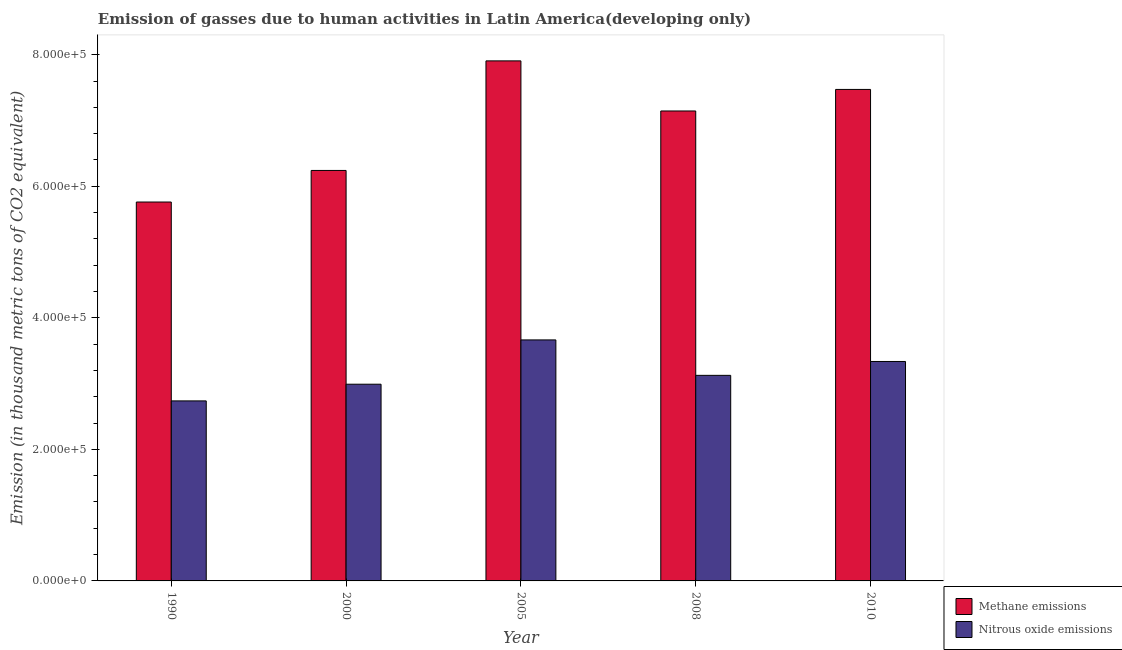How many different coloured bars are there?
Offer a terse response. 2. How many groups of bars are there?
Make the answer very short. 5. Are the number of bars per tick equal to the number of legend labels?
Ensure brevity in your answer.  Yes. Are the number of bars on each tick of the X-axis equal?
Provide a short and direct response. Yes. What is the amount of nitrous oxide emissions in 2010?
Offer a very short reply. 3.34e+05. Across all years, what is the maximum amount of methane emissions?
Provide a short and direct response. 7.91e+05. Across all years, what is the minimum amount of nitrous oxide emissions?
Give a very brief answer. 2.74e+05. In which year was the amount of methane emissions maximum?
Your answer should be compact. 2005. In which year was the amount of methane emissions minimum?
Offer a terse response. 1990. What is the total amount of methane emissions in the graph?
Offer a very short reply. 3.45e+06. What is the difference between the amount of nitrous oxide emissions in 2000 and that in 2008?
Keep it short and to the point. -1.35e+04. What is the difference between the amount of methane emissions in 2005 and the amount of nitrous oxide emissions in 2010?
Offer a very short reply. 4.34e+04. What is the average amount of nitrous oxide emissions per year?
Your response must be concise. 3.17e+05. In how many years, is the amount of methane emissions greater than 680000 thousand metric tons?
Keep it short and to the point. 3. What is the ratio of the amount of nitrous oxide emissions in 1990 to that in 2000?
Your answer should be compact. 0.92. Is the amount of nitrous oxide emissions in 2000 less than that in 2005?
Ensure brevity in your answer.  Yes. What is the difference between the highest and the second highest amount of methane emissions?
Your response must be concise. 4.34e+04. What is the difference between the highest and the lowest amount of nitrous oxide emissions?
Ensure brevity in your answer.  9.27e+04. In how many years, is the amount of methane emissions greater than the average amount of methane emissions taken over all years?
Provide a succinct answer. 3. What does the 2nd bar from the left in 2000 represents?
Give a very brief answer. Nitrous oxide emissions. What does the 2nd bar from the right in 2000 represents?
Your response must be concise. Methane emissions. How many years are there in the graph?
Offer a very short reply. 5. Does the graph contain any zero values?
Your answer should be very brief. No. What is the title of the graph?
Keep it short and to the point. Emission of gasses due to human activities in Latin America(developing only). What is the label or title of the Y-axis?
Your answer should be compact. Emission (in thousand metric tons of CO2 equivalent). What is the Emission (in thousand metric tons of CO2 equivalent) of Methane emissions in 1990?
Provide a short and direct response. 5.76e+05. What is the Emission (in thousand metric tons of CO2 equivalent) of Nitrous oxide emissions in 1990?
Keep it short and to the point. 2.74e+05. What is the Emission (in thousand metric tons of CO2 equivalent) of Methane emissions in 2000?
Make the answer very short. 6.24e+05. What is the Emission (in thousand metric tons of CO2 equivalent) of Nitrous oxide emissions in 2000?
Provide a short and direct response. 2.99e+05. What is the Emission (in thousand metric tons of CO2 equivalent) in Methane emissions in 2005?
Provide a short and direct response. 7.91e+05. What is the Emission (in thousand metric tons of CO2 equivalent) of Nitrous oxide emissions in 2005?
Ensure brevity in your answer.  3.66e+05. What is the Emission (in thousand metric tons of CO2 equivalent) in Methane emissions in 2008?
Your answer should be very brief. 7.15e+05. What is the Emission (in thousand metric tons of CO2 equivalent) in Nitrous oxide emissions in 2008?
Ensure brevity in your answer.  3.13e+05. What is the Emission (in thousand metric tons of CO2 equivalent) of Methane emissions in 2010?
Keep it short and to the point. 7.47e+05. What is the Emission (in thousand metric tons of CO2 equivalent) of Nitrous oxide emissions in 2010?
Offer a terse response. 3.34e+05. Across all years, what is the maximum Emission (in thousand metric tons of CO2 equivalent) in Methane emissions?
Make the answer very short. 7.91e+05. Across all years, what is the maximum Emission (in thousand metric tons of CO2 equivalent) in Nitrous oxide emissions?
Provide a short and direct response. 3.66e+05. Across all years, what is the minimum Emission (in thousand metric tons of CO2 equivalent) of Methane emissions?
Offer a terse response. 5.76e+05. Across all years, what is the minimum Emission (in thousand metric tons of CO2 equivalent) of Nitrous oxide emissions?
Your answer should be very brief. 2.74e+05. What is the total Emission (in thousand metric tons of CO2 equivalent) in Methane emissions in the graph?
Your answer should be compact. 3.45e+06. What is the total Emission (in thousand metric tons of CO2 equivalent) of Nitrous oxide emissions in the graph?
Make the answer very short. 1.59e+06. What is the difference between the Emission (in thousand metric tons of CO2 equivalent) in Methane emissions in 1990 and that in 2000?
Keep it short and to the point. -4.80e+04. What is the difference between the Emission (in thousand metric tons of CO2 equivalent) of Nitrous oxide emissions in 1990 and that in 2000?
Give a very brief answer. -2.54e+04. What is the difference between the Emission (in thousand metric tons of CO2 equivalent) in Methane emissions in 1990 and that in 2005?
Give a very brief answer. -2.15e+05. What is the difference between the Emission (in thousand metric tons of CO2 equivalent) in Nitrous oxide emissions in 1990 and that in 2005?
Your response must be concise. -9.27e+04. What is the difference between the Emission (in thousand metric tons of CO2 equivalent) of Methane emissions in 1990 and that in 2008?
Make the answer very short. -1.38e+05. What is the difference between the Emission (in thousand metric tons of CO2 equivalent) of Nitrous oxide emissions in 1990 and that in 2008?
Provide a succinct answer. -3.89e+04. What is the difference between the Emission (in thousand metric tons of CO2 equivalent) of Methane emissions in 1990 and that in 2010?
Give a very brief answer. -1.71e+05. What is the difference between the Emission (in thousand metric tons of CO2 equivalent) of Nitrous oxide emissions in 1990 and that in 2010?
Ensure brevity in your answer.  -6.00e+04. What is the difference between the Emission (in thousand metric tons of CO2 equivalent) of Methane emissions in 2000 and that in 2005?
Make the answer very short. -1.67e+05. What is the difference between the Emission (in thousand metric tons of CO2 equivalent) of Nitrous oxide emissions in 2000 and that in 2005?
Offer a very short reply. -6.74e+04. What is the difference between the Emission (in thousand metric tons of CO2 equivalent) of Methane emissions in 2000 and that in 2008?
Your answer should be compact. -9.04e+04. What is the difference between the Emission (in thousand metric tons of CO2 equivalent) in Nitrous oxide emissions in 2000 and that in 2008?
Your answer should be very brief. -1.35e+04. What is the difference between the Emission (in thousand metric tons of CO2 equivalent) of Methane emissions in 2000 and that in 2010?
Keep it short and to the point. -1.23e+05. What is the difference between the Emission (in thousand metric tons of CO2 equivalent) in Nitrous oxide emissions in 2000 and that in 2010?
Keep it short and to the point. -3.46e+04. What is the difference between the Emission (in thousand metric tons of CO2 equivalent) in Methane emissions in 2005 and that in 2008?
Provide a succinct answer. 7.62e+04. What is the difference between the Emission (in thousand metric tons of CO2 equivalent) in Nitrous oxide emissions in 2005 and that in 2008?
Give a very brief answer. 5.39e+04. What is the difference between the Emission (in thousand metric tons of CO2 equivalent) of Methane emissions in 2005 and that in 2010?
Ensure brevity in your answer.  4.34e+04. What is the difference between the Emission (in thousand metric tons of CO2 equivalent) in Nitrous oxide emissions in 2005 and that in 2010?
Make the answer very short. 3.28e+04. What is the difference between the Emission (in thousand metric tons of CO2 equivalent) in Methane emissions in 2008 and that in 2010?
Offer a very short reply. -3.27e+04. What is the difference between the Emission (in thousand metric tons of CO2 equivalent) of Nitrous oxide emissions in 2008 and that in 2010?
Your answer should be compact. -2.11e+04. What is the difference between the Emission (in thousand metric tons of CO2 equivalent) in Methane emissions in 1990 and the Emission (in thousand metric tons of CO2 equivalent) in Nitrous oxide emissions in 2000?
Your answer should be very brief. 2.77e+05. What is the difference between the Emission (in thousand metric tons of CO2 equivalent) of Methane emissions in 1990 and the Emission (in thousand metric tons of CO2 equivalent) of Nitrous oxide emissions in 2005?
Offer a terse response. 2.10e+05. What is the difference between the Emission (in thousand metric tons of CO2 equivalent) of Methane emissions in 1990 and the Emission (in thousand metric tons of CO2 equivalent) of Nitrous oxide emissions in 2008?
Provide a succinct answer. 2.64e+05. What is the difference between the Emission (in thousand metric tons of CO2 equivalent) in Methane emissions in 1990 and the Emission (in thousand metric tons of CO2 equivalent) in Nitrous oxide emissions in 2010?
Offer a very short reply. 2.42e+05. What is the difference between the Emission (in thousand metric tons of CO2 equivalent) in Methane emissions in 2000 and the Emission (in thousand metric tons of CO2 equivalent) in Nitrous oxide emissions in 2005?
Give a very brief answer. 2.58e+05. What is the difference between the Emission (in thousand metric tons of CO2 equivalent) of Methane emissions in 2000 and the Emission (in thousand metric tons of CO2 equivalent) of Nitrous oxide emissions in 2008?
Offer a terse response. 3.12e+05. What is the difference between the Emission (in thousand metric tons of CO2 equivalent) in Methane emissions in 2000 and the Emission (in thousand metric tons of CO2 equivalent) in Nitrous oxide emissions in 2010?
Offer a very short reply. 2.90e+05. What is the difference between the Emission (in thousand metric tons of CO2 equivalent) in Methane emissions in 2005 and the Emission (in thousand metric tons of CO2 equivalent) in Nitrous oxide emissions in 2008?
Your answer should be very brief. 4.78e+05. What is the difference between the Emission (in thousand metric tons of CO2 equivalent) in Methane emissions in 2005 and the Emission (in thousand metric tons of CO2 equivalent) in Nitrous oxide emissions in 2010?
Offer a terse response. 4.57e+05. What is the difference between the Emission (in thousand metric tons of CO2 equivalent) in Methane emissions in 2008 and the Emission (in thousand metric tons of CO2 equivalent) in Nitrous oxide emissions in 2010?
Keep it short and to the point. 3.81e+05. What is the average Emission (in thousand metric tons of CO2 equivalent) of Methane emissions per year?
Offer a very short reply. 6.91e+05. What is the average Emission (in thousand metric tons of CO2 equivalent) in Nitrous oxide emissions per year?
Ensure brevity in your answer.  3.17e+05. In the year 1990, what is the difference between the Emission (in thousand metric tons of CO2 equivalent) of Methane emissions and Emission (in thousand metric tons of CO2 equivalent) of Nitrous oxide emissions?
Your answer should be very brief. 3.02e+05. In the year 2000, what is the difference between the Emission (in thousand metric tons of CO2 equivalent) of Methane emissions and Emission (in thousand metric tons of CO2 equivalent) of Nitrous oxide emissions?
Give a very brief answer. 3.25e+05. In the year 2005, what is the difference between the Emission (in thousand metric tons of CO2 equivalent) in Methane emissions and Emission (in thousand metric tons of CO2 equivalent) in Nitrous oxide emissions?
Make the answer very short. 4.24e+05. In the year 2008, what is the difference between the Emission (in thousand metric tons of CO2 equivalent) in Methane emissions and Emission (in thousand metric tons of CO2 equivalent) in Nitrous oxide emissions?
Your response must be concise. 4.02e+05. In the year 2010, what is the difference between the Emission (in thousand metric tons of CO2 equivalent) of Methane emissions and Emission (in thousand metric tons of CO2 equivalent) of Nitrous oxide emissions?
Keep it short and to the point. 4.14e+05. What is the ratio of the Emission (in thousand metric tons of CO2 equivalent) in Methane emissions in 1990 to that in 2000?
Ensure brevity in your answer.  0.92. What is the ratio of the Emission (in thousand metric tons of CO2 equivalent) of Nitrous oxide emissions in 1990 to that in 2000?
Offer a terse response. 0.92. What is the ratio of the Emission (in thousand metric tons of CO2 equivalent) of Methane emissions in 1990 to that in 2005?
Ensure brevity in your answer.  0.73. What is the ratio of the Emission (in thousand metric tons of CO2 equivalent) of Nitrous oxide emissions in 1990 to that in 2005?
Your response must be concise. 0.75. What is the ratio of the Emission (in thousand metric tons of CO2 equivalent) of Methane emissions in 1990 to that in 2008?
Offer a very short reply. 0.81. What is the ratio of the Emission (in thousand metric tons of CO2 equivalent) of Nitrous oxide emissions in 1990 to that in 2008?
Provide a succinct answer. 0.88. What is the ratio of the Emission (in thousand metric tons of CO2 equivalent) in Methane emissions in 1990 to that in 2010?
Offer a very short reply. 0.77. What is the ratio of the Emission (in thousand metric tons of CO2 equivalent) in Nitrous oxide emissions in 1990 to that in 2010?
Ensure brevity in your answer.  0.82. What is the ratio of the Emission (in thousand metric tons of CO2 equivalent) of Methane emissions in 2000 to that in 2005?
Your response must be concise. 0.79. What is the ratio of the Emission (in thousand metric tons of CO2 equivalent) of Nitrous oxide emissions in 2000 to that in 2005?
Provide a succinct answer. 0.82. What is the ratio of the Emission (in thousand metric tons of CO2 equivalent) of Methane emissions in 2000 to that in 2008?
Keep it short and to the point. 0.87. What is the ratio of the Emission (in thousand metric tons of CO2 equivalent) in Nitrous oxide emissions in 2000 to that in 2008?
Keep it short and to the point. 0.96. What is the ratio of the Emission (in thousand metric tons of CO2 equivalent) of Methane emissions in 2000 to that in 2010?
Give a very brief answer. 0.84. What is the ratio of the Emission (in thousand metric tons of CO2 equivalent) in Nitrous oxide emissions in 2000 to that in 2010?
Provide a short and direct response. 0.9. What is the ratio of the Emission (in thousand metric tons of CO2 equivalent) of Methane emissions in 2005 to that in 2008?
Give a very brief answer. 1.11. What is the ratio of the Emission (in thousand metric tons of CO2 equivalent) in Nitrous oxide emissions in 2005 to that in 2008?
Make the answer very short. 1.17. What is the ratio of the Emission (in thousand metric tons of CO2 equivalent) in Methane emissions in 2005 to that in 2010?
Your answer should be compact. 1.06. What is the ratio of the Emission (in thousand metric tons of CO2 equivalent) in Nitrous oxide emissions in 2005 to that in 2010?
Give a very brief answer. 1.1. What is the ratio of the Emission (in thousand metric tons of CO2 equivalent) in Methane emissions in 2008 to that in 2010?
Give a very brief answer. 0.96. What is the ratio of the Emission (in thousand metric tons of CO2 equivalent) in Nitrous oxide emissions in 2008 to that in 2010?
Provide a succinct answer. 0.94. What is the difference between the highest and the second highest Emission (in thousand metric tons of CO2 equivalent) in Methane emissions?
Provide a short and direct response. 4.34e+04. What is the difference between the highest and the second highest Emission (in thousand metric tons of CO2 equivalent) of Nitrous oxide emissions?
Provide a short and direct response. 3.28e+04. What is the difference between the highest and the lowest Emission (in thousand metric tons of CO2 equivalent) of Methane emissions?
Offer a very short reply. 2.15e+05. What is the difference between the highest and the lowest Emission (in thousand metric tons of CO2 equivalent) in Nitrous oxide emissions?
Offer a very short reply. 9.27e+04. 